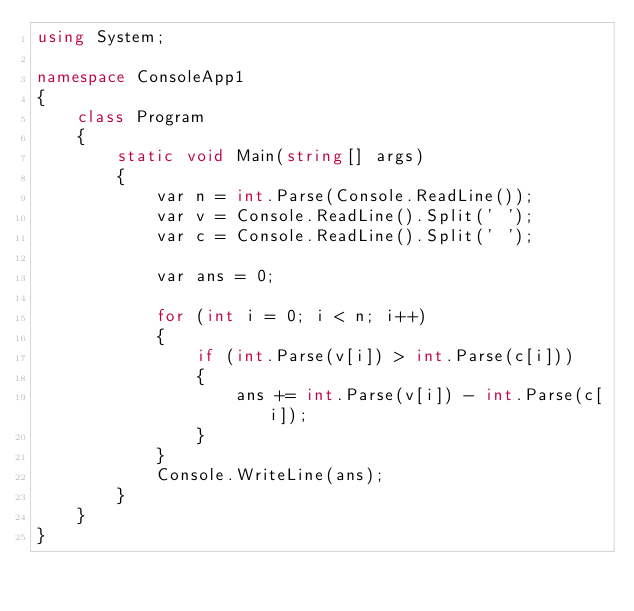Convert code to text. <code><loc_0><loc_0><loc_500><loc_500><_C#_>using System;

namespace ConsoleApp1
{
    class Program
    {
        static void Main(string[] args)
        {
            var n = int.Parse(Console.ReadLine());
            var v = Console.ReadLine().Split(' ');
            var c = Console.ReadLine().Split(' ');

            var ans = 0;

            for (int i = 0; i < n; i++)
            {
                if (int.Parse(v[i]) > int.Parse(c[i]))
                {
                    ans += int.Parse(v[i]) - int.Parse(c[i]);
                }
            }
            Console.WriteLine(ans);
        }
    }
}
</code> 